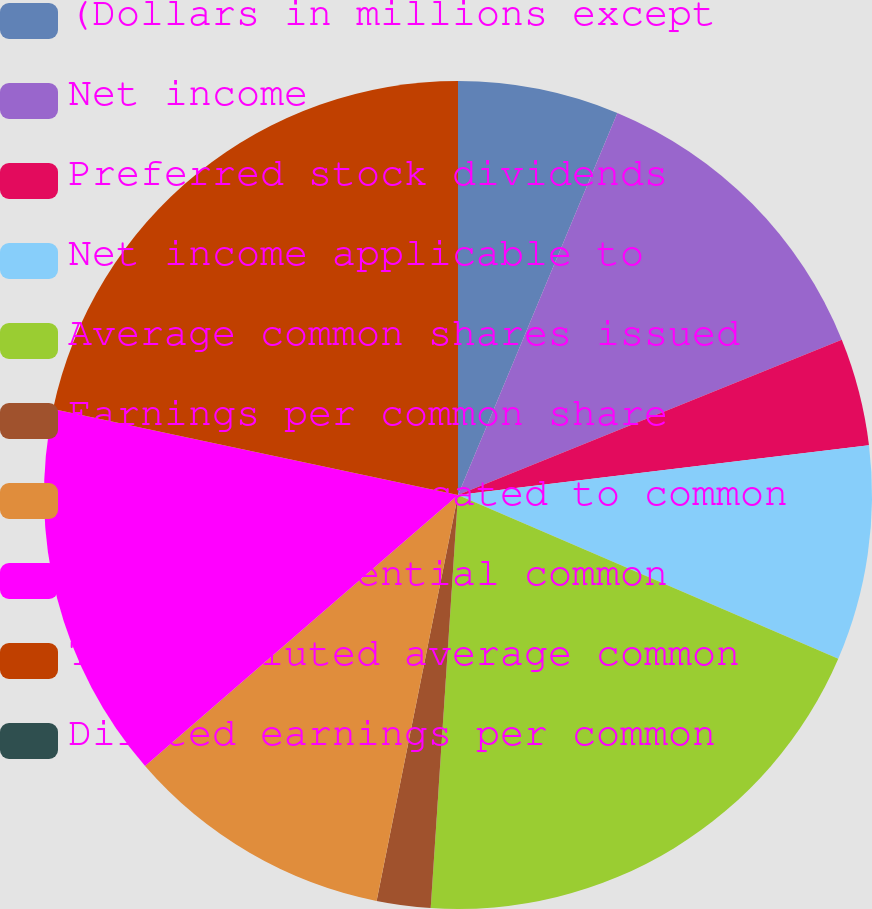Convert chart. <chart><loc_0><loc_0><loc_500><loc_500><pie_chart><fcel>(Dollars in millions except<fcel>Net income<fcel>Preferred stock dividends<fcel>Net income applicable to<fcel>Average common shares issued<fcel>Earnings per common share<fcel>Net income allocated to common<fcel>Dilutive potential common<fcel>Total diluted average common<fcel>Diluted earnings per common<nl><fcel>6.29%<fcel>12.59%<fcel>4.2%<fcel>8.39%<fcel>19.58%<fcel>2.1%<fcel>10.49%<fcel>14.69%<fcel>21.67%<fcel>0.0%<nl></chart> 